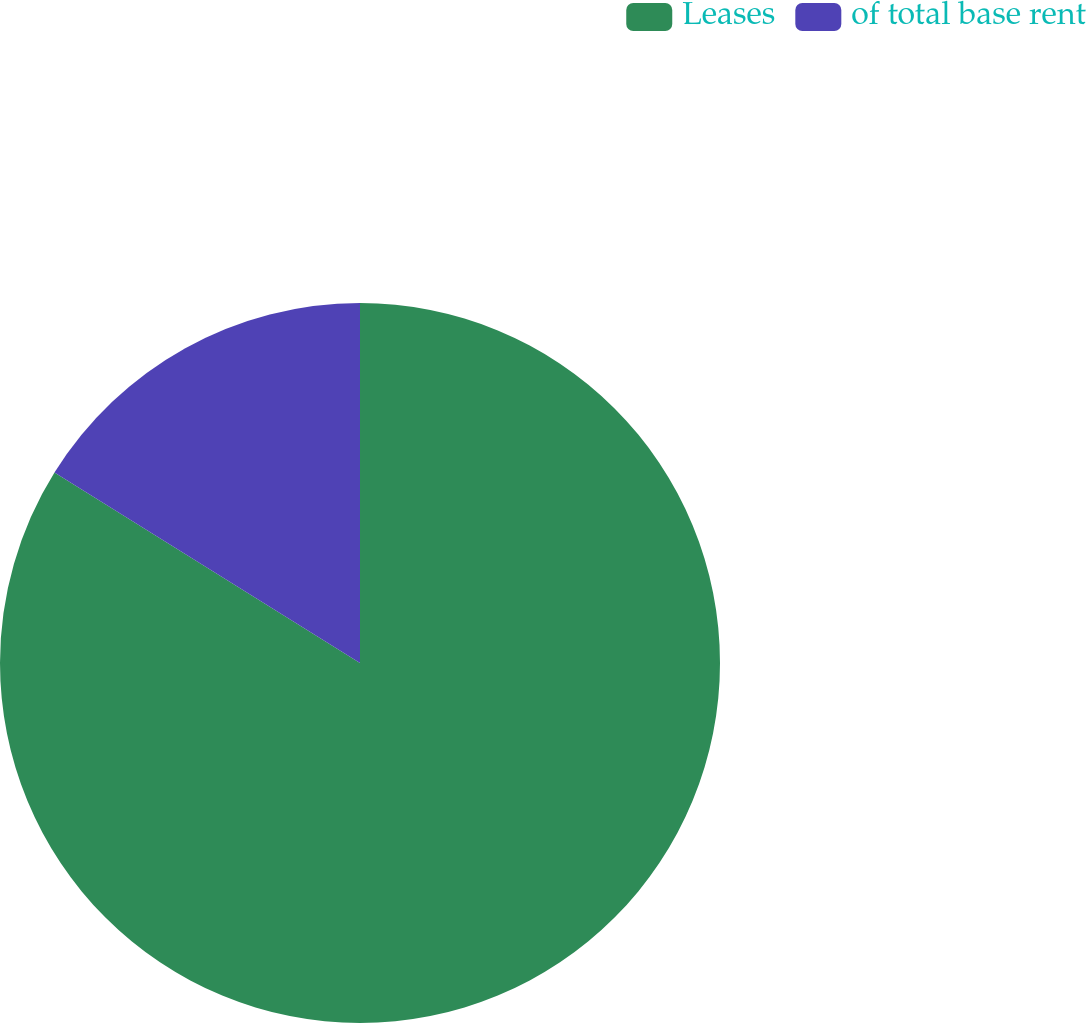<chart> <loc_0><loc_0><loc_500><loc_500><pie_chart><fcel>Leases<fcel>of total base rent<nl><fcel>83.87%<fcel>16.13%<nl></chart> 